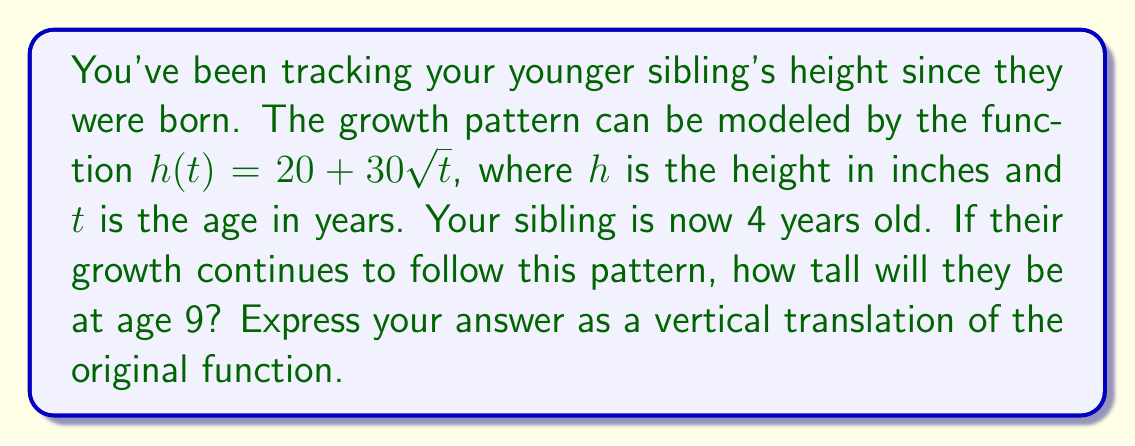Help me with this question. Let's approach this step-by-step:

1) First, we need to find the current height of the sibling at age 4:
   $h(4) = 20 + 30\sqrt{4} = 20 + 30(2) = 80$ inches

2) Now, we want to find the height at age 9:
   $h(9) = 20 + 30\sqrt{9} = 20 + 30(3) = 110$ inches

3) To express this as a vertical translation, we need to find the difference between these heights:
   $110 - 80 = 30$ inches

4) This means the height at age 9 can be expressed as a vertical translation of the height at age 4 by 30 inches upward.

5) In function notation, this can be written as:
   $h_{9}(t) = h(t) + 30$

6) Substituting the original function:
   $h_{9}(t) = (20 + 30\sqrt{t}) + 30$

7) Simplifying:
   $h_{9}(t) = 50 + 30\sqrt{t}$

This new function represents the height at age 9 as a vertical translation of the original function by 30 inches upward.
Answer: $h_{9}(t) = 50 + 30\sqrt{t}$ 